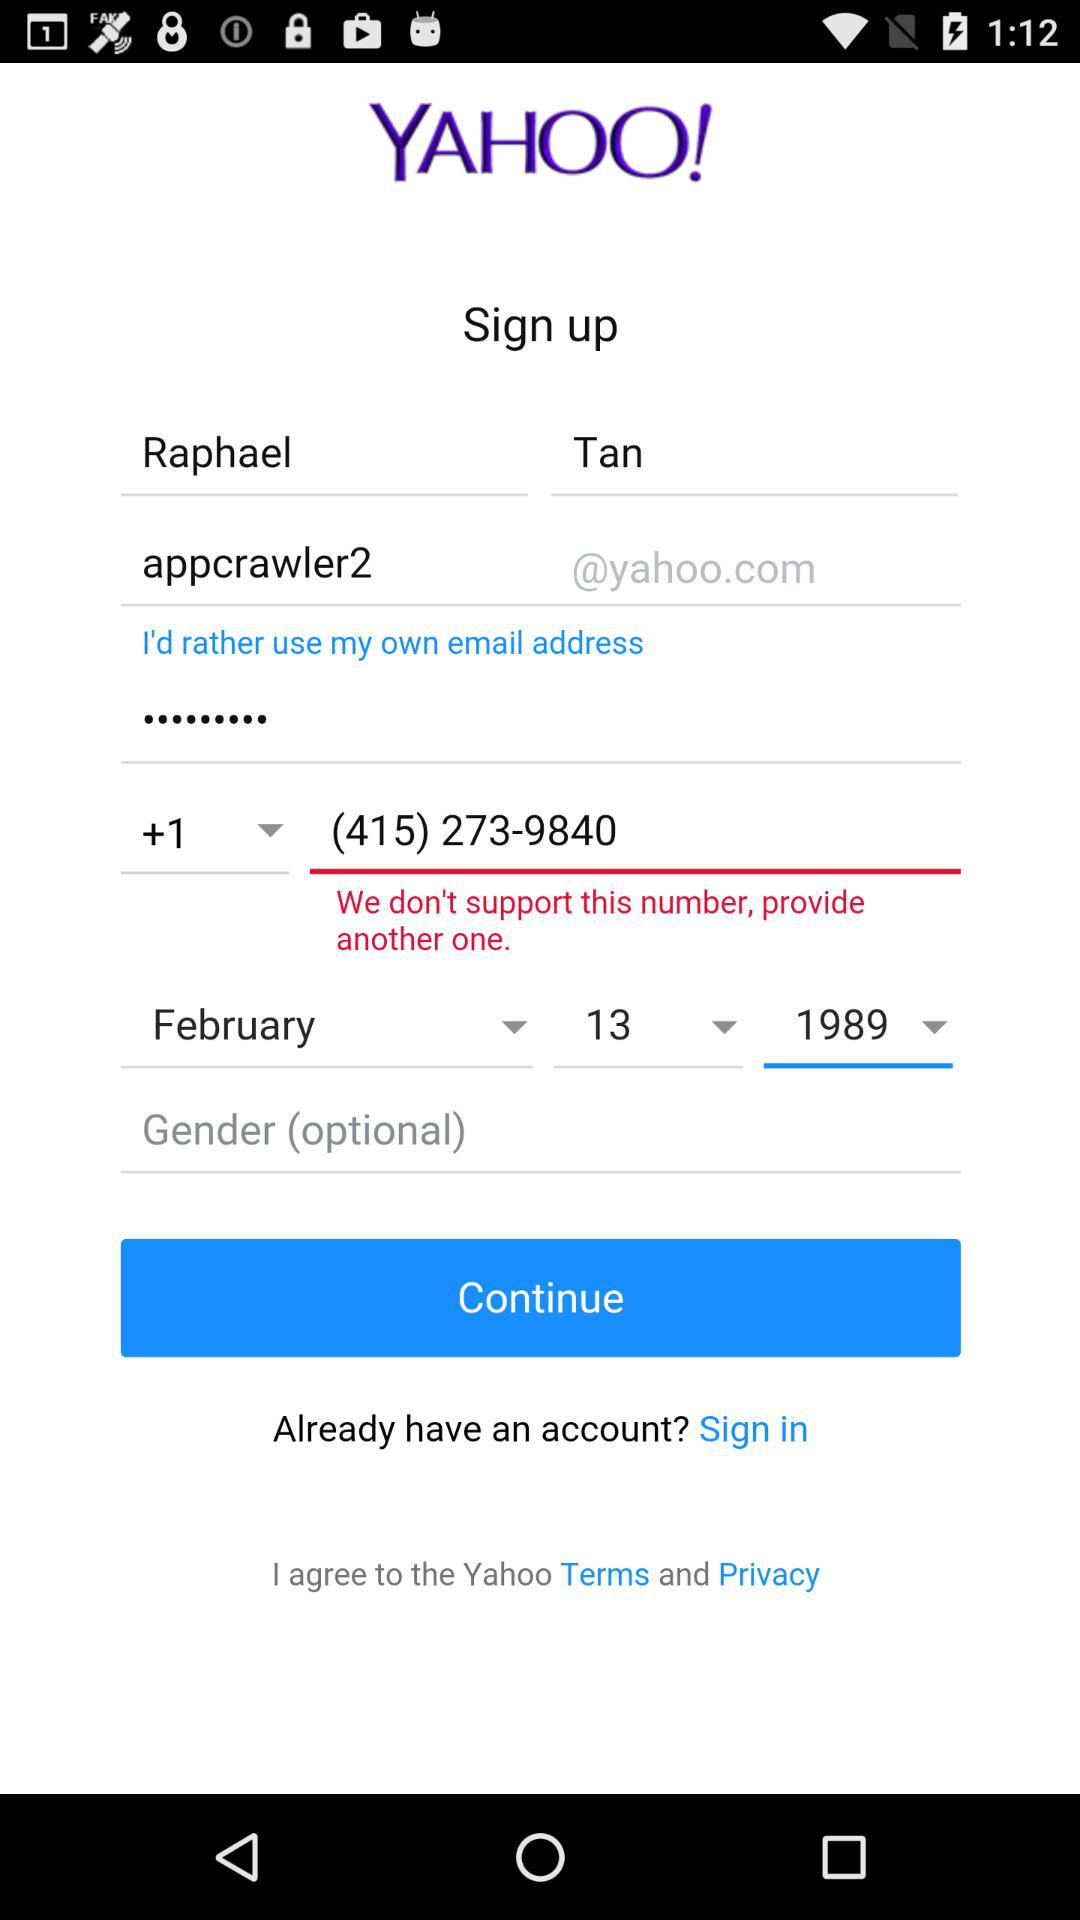What is the user name? The user name is Raphael Tan. 